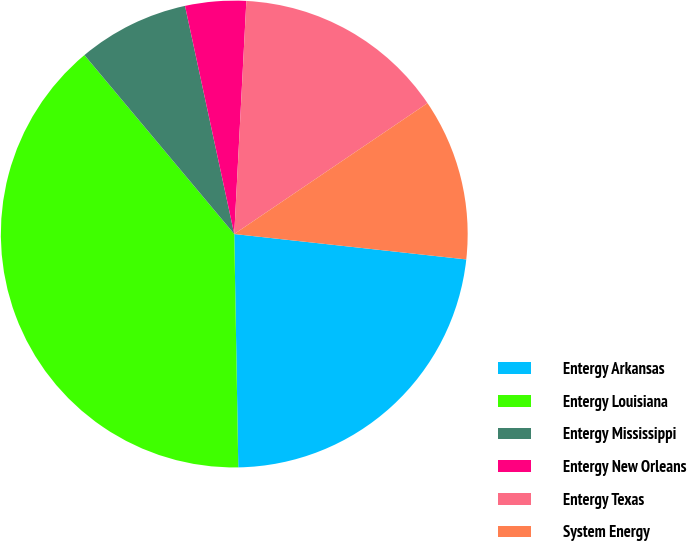<chart> <loc_0><loc_0><loc_500><loc_500><pie_chart><fcel>Entergy Arkansas<fcel>Entergy Louisiana<fcel>Entergy Mississippi<fcel>Entergy New Orleans<fcel>Entergy Texas<fcel>System Energy<nl><fcel>22.99%<fcel>39.18%<fcel>7.71%<fcel>4.21%<fcel>14.7%<fcel>11.21%<nl></chart> 